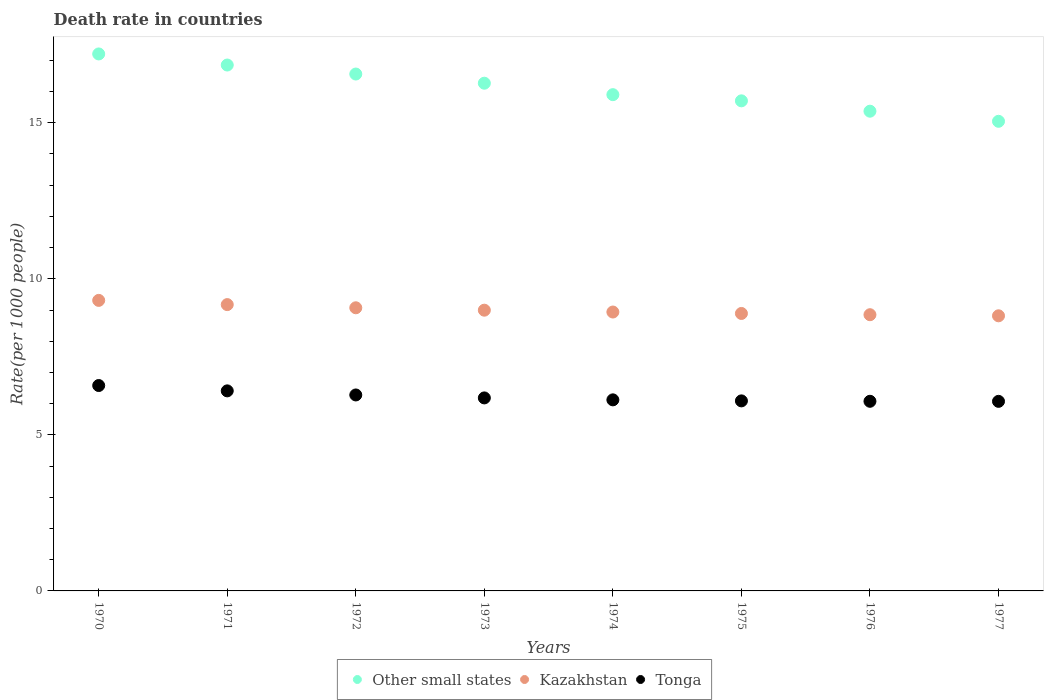How many different coloured dotlines are there?
Provide a short and direct response. 3. Is the number of dotlines equal to the number of legend labels?
Your answer should be compact. Yes. What is the death rate in Tonga in 1970?
Offer a very short reply. 6.58. Across all years, what is the maximum death rate in Kazakhstan?
Provide a succinct answer. 9.31. Across all years, what is the minimum death rate in Kazakhstan?
Your answer should be very brief. 8.81. In which year was the death rate in Kazakhstan maximum?
Your response must be concise. 1970. In which year was the death rate in Other small states minimum?
Provide a short and direct response. 1977. What is the total death rate in Tonga in the graph?
Provide a short and direct response. 49.82. What is the difference between the death rate in Kazakhstan in 1972 and that in 1973?
Your response must be concise. 0.08. What is the difference between the death rate in Kazakhstan in 1973 and the death rate in Tonga in 1976?
Offer a very short reply. 2.92. What is the average death rate in Kazakhstan per year?
Your answer should be very brief. 9.01. In the year 1977, what is the difference between the death rate in Tonga and death rate in Other small states?
Give a very brief answer. -8.97. In how many years, is the death rate in Other small states greater than 8?
Make the answer very short. 8. What is the ratio of the death rate in Tonga in 1970 to that in 1977?
Keep it short and to the point. 1.08. Is the difference between the death rate in Tonga in 1972 and 1977 greater than the difference between the death rate in Other small states in 1972 and 1977?
Keep it short and to the point. No. What is the difference between the highest and the second highest death rate in Tonga?
Make the answer very short. 0.17. What is the difference between the highest and the lowest death rate in Tonga?
Make the answer very short. 0.51. Is the sum of the death rate in Kazakhstan in 1971 and 1972 greater than the maximum death rate in Tonga across all years?
Keep it short and to the point. Yes. How many dotlines are there?
Keep it short and to the point. 3. How many years are there in the graph?
Keep it short and to the point. 8. What is the difference between two consecutive major ticks on the Y-axis?
Provide a succinct answer. 5. Does the graph contain any zero values?
Offer a terse response. No. Where does the legend appear in the graph?
Offer a very short reply. Bottom center. How many legend labels are there?
Keep it short and to the point. 3. How are the legend labels stacked?
Provide a succinct answer. Horizontal. What is the title of the graph?
Offer a terse response. Death rate in countries. Does "Low & middle income" appear as one of the legend labels in the graph?
Your answer should be very brief. No. What is the label or title of the X-axis?
Provide a succinct answer. Years. What is the label or title of the Y-axis?
Offer a very short reply. Rate(per 1000 people). What is the Rate(per 1000 people) of Other small states in 1970?
Your answer should be very brief. 17.21. What is the Rate(per 1000 people) of Kazakhstan in 1970?
Give a very brief answer. 9.31. What is the Rate(per 1000 people) in Tonga in 1970?
Provide a succinct answer. 6.58. What is the Rate(per 1000 people) of Other small states in 1971?
Make the answer very short. 16.85. What is the Rate(per 1000 people) in Kazakhstan in 1971?
Ensure brevity in your answer.  9.17. What is the Rate(per 1000 people) of Tonga in 1971?
Provide a short and direct response. 6.41. What is the Rate(per 1000 people) in Other small states in 1972?
Give a very brief answer. 16.56. What is the Rate(per 1000 people) in Kazakhstan in 1972?
Give a very brief answer. 9.07. What is the Rate(per 1000 people) in Tonga in 1972?
Your answer should be compact. 6.28. What is the Rate(per 1000 people) in Other small states in 1973?
Your answer should be very brief. 16.27. What is the Rate(per 1000 people) of Kazakhstan in 1973?
Ensure brevity in your answer.  8.99. What is the Rate(per 1000 people) of Tonga in 1973?
Make the answer very short. 6.18. What is the Rate(per 1000 people) in Other small states in 1974?
Make the answer very short. 15.9. What is the Rate(per 1000 people) in Kazakhstan in 1974?
Offer a terse response. 8.94. What is the Rate(per 1000 people) in Tonga in 1974?
Give a very brief answer. 6.12. What is the Rate(per 1000 people) in Other small states in 1975?
Make the answer very short. 15.7. What is the Rate(per 1000 people) of Kazakhstan in 1975?
Your answer should be very brief. 8.89. What is the Rate(per 1000 people) in Tonga in 1975?
Provide a short and direct response. 6.09. What is the Rate(per 1000 people) in Other small states in 1976?
Keep it short and to the point. 15.37. What is the Rate(per 1000 people) of Kazakhstan in 1976?
Provide a short and direct response. 8.85. What is the Rate(per 1000 people) of Tonga in 1976?
Offer a terse response. 6.08. What is the Rate(per 1000 people) of Other small states in 1977?
Your answer should be very brief. 15.05. What is the Rate(per 1000 people) in Kazakhstan in 1977?
Your answer should be compact. 8.81. What is the Rate(per 1000 people) of Tonga in 1977?
Provide a short and direct response. 6.07. Across all years, what is the maximum Rate(per 1000 people) of Other small states?
Offer a very short reply. 17.21. Across all years, what is the maximum Rate(per 1000 people) of Kazakhstan?
Your answer should be very brief. 9.31. Across all years, what is the maximum Rate(per 1000 people) of Tonga?
Offer a very short reply. 6.58. Across all years, what is the minimum Rate(per 1000 people) of Other small states?
Offer a very short reply. 15.05. Across all years, what is the minimum Rate(per 1000 people) of Kazakhstan?
Provide a short and direct response. 8.81. Across all years, what is the minimum Rate(per 1000 people) in Tonga?
Give a very brief answer. 6.07. What is the total Rate(per 1000 people) of Other small states in the graph?
Provide a succinct answer. 128.91. What is the total Rate(per 1000 people) in Kazakhstan in the graph?
Ensure brevity in your answer.  72.04. What is the total Rate(per 1000 people) of Tonga in the graph?
Provide a short and direct response. 49.81. What is the difference between the Rate(per 1000 people) in Other small states in 1970 and that in 1971?
Give a very brief answer. 0.36. What is the difference between the Rate(per 1000 people) of Kazakhstan in 1970 and that in 1971?
Keep it short and to the point. 0.14. What is the difference between the Rate(per 1000 people) in Tonga in 1970 and that in 1971?
Provide a succinct answer. 0.17. What is the difference between the Rate(per 1000 people) in Other small states in 1970 and that in 1972?
Your answer should be very brief. 0.64. What is the difference between the Rate(per 1000 people) in Kazakhstan in 1970 and that in 1972?
Your response must be concise. 0.24. What is the difference between the Rate(per 1000 people) in Tonga in 1970 and that in 1972?
Offer a terse response. 0.3. What is the difference between the Rate(per 1000 people) of Kazakhstan in 1970 and that in 1973?
Your answer should be compact. 0.31. What is the difference between the Rate(per 1000 people) in Tonga in 1970 and that in 1973?
Provide a short and direct response. 0.4. What is the difference between the Rate(per 1000 people) of Other small states in 1970 and that in 1974?
Offer a very short reply. 1.3. What is the difference between the Rate(per 1000 people) in Kazakhstan in 1970 and that in 1974?
Offer a terse response. 0.37. What is the difference between the Rate(per 1000 people) of Tonga in 1970 and that in 1974?
Keep it short and to the point. 0.46. What is the difference between the Rate(per 1000 people) in Other small states in 1970 and that in 1975?
Your response must be concise. 1.5. What is the difference between the Rate(per 1000 people) of Kazakhstan in 1970 and that in 1975?
Ensure brevity in your answer.  0.42. What is the difference between the Rate(per 1000 people) in Tonga in 1970 and that in 1975?
Your answer should be compact. 0.49. What is the difference between the Rate(per 1000 people) of Other small states in 1970 and that in 1976?
Provide a succinct answer. 1.83. What is the difference between the Rate(per 1000 people) in Kazakhstan in 1970 and that in 1976?
Offer a very short reply. 0.46. What is the difference between the Rate(per 1000 people) of Tonga in 1970 and that in 1976?
Your response must be concise. 0.51. What is the difference between the Rate(per 1000 people) in Other small states in 1970 and that in 1977?
Keep it short and to the point. 2.16. What is the difference between the Rate(per 1000 people) of Kazakhstan in 1970 and that in 1977?
Give a very brief answer. 0.49. What is the difference between the Rate(per 1000 people) of Tonga in 1970 and that in 1977?
Offer a very short reply. 0.51. What is the difference between the Rate(per 1000 people) of Other small states in 1971 and that in 1972?
Provide a succinct answer. 0.29. What is the difference between the Rate(per 1000 people) in Kazakhstan in 1971 and that in 1972?
Your response must be concise. 0.1. What is the difference between the Rate(per 1000 people) of Tonga in 1971 and that in 1972?
Ensure brevity in your answer.  0.13. What is the difference between the Rate(per 1000 people) in Other small states in 1971 and that in 1973?
Offer a very short reply. 0.58. What is the difference between the Rate(per 1000 people) of Kazakhstan in 1971 and that in 1973?
Provide a short and direct response. 0.18. What is the difference between the Rate(per 1000 people) in Tonga in 1971 and that in 1973?
Offer a terse response. 0.23. What is the difference between the Rate(per 1000 people) of Other small states in 1971 and that in 1974?
Provide a succinct answer. 0.95. What is the difference between the Rate(per 1000 people) in Kazakhstan in 1971 and that in 1974?
Your answer should be compact. 0.24. What is the difference between the Rate(per 1000 people) of Tonga in 1971 and that in 1974?
Provide a short and direct response. 0.29. What is the difference between the Rate(per 1000 people) in Other small states in 1971 and that in 1975?
Ensure brevity in your answer.  1.15. What is the difference between the Rate(per 1000 people) in Kazakhstan in 1971 and that in 1975?
Your response must be concise. 0.28. What is the difference between the Rate(per 1000 people) of Tonga in 1971 and that in 1975?
Make the answer very short. 0.32. What is the difference between the Rate(per 1000 people) in Other small states in 1971 and that in 1976?
Make the answer very short. 1.48. What is the difference between the Rate(per 1000 people) in Kazakhstan in 1971 and that in 1976?
Offer a very short reply. 0.32. What is the difference between the Rate(per 1000 people) in Tonga in 1971 and that in 1976?
Offer a terse response. 0.33. What is the difference between the Rate(per 1000 people) of Other small states in 1971 and that in 1977?
Provide a succinct answer. 1.8. What is the difference between the Rate(per 1000 people) in Kazakhstan in 1971 and that in 1977?
Provide a succinct answer. 0.36. What is the difference between the Rate(per 1000 people) in Tonga in 1971 and that in 1977?
Provide a short and direct response. 0.34. What is the difference between the Rate(per 1000 people) of Other small states in 1972 and that in 1973?
Provide a succinct answer. 0.29. What is the difference between the Rate(per 1000 people) in Kazakhstan in 1972 and that in 1973?
Make the answer very short. 0.08. What is the difference between the Rate(per 1000 people) in Tonga in 1972 and that in 1973?
Your answer should be compact. 0.1. What is the difference between the Rate(per 1000 people) of Other small states in 1972 and that in 1974?
Provide a succinct answer. 0.66. What is the difference between the Rate(per 1000 people) in Kazakhstan in 1972 and that in 1974?
Make the answer very short. 0.14. What is the difference between the Rate(per 1000 people) in Tonga in 1972 and that in 1974?
Your answer should be compact. 0.16. What is the difference between the Rate(per 1000 people) of Other small states in 1972 and that in 1975?
Your response must be concise. 0.86. What is the difference between the Rate(per 1000 people) in Kazakhstan in 1972 and that in 1975?
Your answer should be compact. 0.18. What is the difference between the Rate(per 1000 people) of Tonga in 1972 and that in 1975?
Provide a short and direct response. 0.19. What is the difference between the Rate(per 1000 people) in Other small states in 1972 and that in 1976?
Offer a terse response. 1.19. What is the difference between the Rate(per 1000 people) of Kazakhstan in 1972 and that in 1976?
Your answer should be very brief. 0.22. What is the difference between the Rate(per 1000 people) of Tonga in 1972 and that in 1976?
Ensure brevity in your answer.  0.2. What is the difference between the Rate(per 1000 people) of Other small states in 1972 and that in 1977?
Provide a short and direct response. 1.51. What is the difference between the Rate(per 1000 people) of Kazakhstan in 1972 and that in 1977?
Ensure brevity in your answer.  0.26. What is the difference between the Rate(per 1000 people) of Tonga in 1972 and that in 1977?
Give a very brief answer. 0.2. What is the difference between the Rate(per 1000 people) of Other small states in 1973 and that in 1974?
Keep it short and to the point. 0.37. What is the difference between the Rate(per 1000 people) of Kazakhstan in 1973 and that in 1974?
Offer a very short reply. 0.06. What is the difference between the Rate(per 1000 people) in Tonga in 1973 and that in 1974?
Your answer should be very brief. 0.06. What is the difference between the Rate(per 1000 people) of Other small states in 1973 and that in 1975?
Offer a very short reply. 0.57. What is the difference between the Rate(per 1000 people) in Kazakhstan in 1973 and that in 1975?
Provide a succinct answer. 0.1. What is the difference between the Rate(per 1000 people) of Tonga in 1973 and that in 1975?
Your answer should be compact. 0.1. What is the difference between the Rate(per 1000 people) in Other small states in 1973 and that in 1976?
Your response must be concise. 0.9. What is the difference between the Rate(per 1000 people) of Kazakhstan in 1973 and that in 1976?
Your answer should be very brief. 0.14. What is the difference between the Rate(per 1000 people) of Tonga in 1973 and that in 1976?
Offer a very short reply. 0.11. What is the difference between the Rate(per 1000 people) in Other small states in 1973 and that in 1977?
Offer a very short reply. 1.22. What is the difference between the Rate(per 1000 people) in Kazakhstan in 1973 and that in 1977?
Offer a very short reply. 0.18. What is the difference between the Rate(per 1000 people) of Tonga in 1973 and that in 1977?
Offer a very short reply. 0.11. What is the difference between the Rate(per 1000 people) of Other small states in 1974 and that in 1975?
Keep it short and to the point. 0.2. What is the difference between the Rate(per 1000 people) of Kazakhstan in 1974 and that in 1975?
Your response must be concise. 0.05. What is the difference between the Rate(per 1000 people) of Tonga in 1974 and that in 1975?
Keep it short and to the point. 0.03. What is the difference between the Rate(per 1000 people) of Other small states in 1974 and that in 1976?
Offer a terse response. 0.53. What is the difference between the Rate(per 1000 people) of Kazakhstan in 1974 and that in 1976?
Provide a short and direct response. 0.09. What is the difference between the Rate(per 1000 people) of Tonga in 1974 and that in 1976?
Ensure brevity in your answer.  0.05. What is the difference between the Rate(per 1000 people) of Other small states in 1974 and that in 1977?
Ensure brevity in your answer.  0.85. What is the difference between the Rate(per 1000 people) of Kazakhstan in 1974 and that in 1977?
Keep it short and to the point. 0.12. What is the difference between the Rate(per 1000 people) in Tonga in 1974 and that in 1977?
Offer a terse response. 0.05. What is the difference between the Rate(per 1000 people) in Other small states in 1975 and that in 1976?
Make the answer very short. 0.33. What is the difference between the Rate(per 1000 people) of Kazakhstan in 1975 and that in 1976?
Your answer should be very brief. 0.04. What is the difference between the Rate(per 1000 people) in Tonga in 1975 and that in 1976?
Your answer should be compact. 0.01. What is the difference between the Rate(per 1000 people) of Other small states in 1975 and that in 1977?
Your answer should be very brief. 0.66. What is the difference between the Rate(per 1000 people) of Kazakhstan in 1975 and that in 1977?
Provide a short and direct response. 0.07. What is the difference between the Rate(per 1000 people) of Tonga in 1975 and that in 1977?
Your answer should be very brief. 0.01. What is the difference between the Rate(per 1000 people) of Other small states in 1976 and that in 1977?
Offer a terse response. 0.32. What is the difference between the Rate(per 1000 people) in Kazakhstan in 1976 and that in 1977?
Offer a very short reply. 0.04. What is the difference between the Rate(per 1000 people) of Tonga in 1976 and that in 1977?
Your response must be concise. 0. What is the difference between the Rate(per 1000 people) of Other small states in 1970 and the Rate(per 1000 people) of Kazakhstan in 1971?
Provide a succinct answer. 8.03. What is the difference between the Rate(per 1000 people) of Other small states in 1970 and the Rate(per 1000 people) of Tonga in 1971?
Make the answer very short. 10.8. What is the difference between the Rate(per 1000 people) in Kazakhstan in 1970 and the Rate(per 1000 people) in Tonga in 1971?
Ensure brevity in your answer.  2.9. What is the difference between the Rate(per 1000 people) in Other small states in 1970 and the Rate(per 1000 people) in Kazakhstan in 1972?
Ensure brevity in your answer.  8.13. What is the difference between the Rate(per 1000 people) of Other small states in 1970 and the Rate(per 1000 people) of Tonga in 1972?
Your response must be concise. 10.93. What is the difference between the Rate(per 1000 people) in Kazakhstan in 1970 and the Rate(per 1000 people) in Tonga in 1972?
Ensure brevity in your answer.  3.03. What is the difference between the Rate(per 1000 people) of Other small states in 1970 and the Rate(per 1000 people) of Kazakhstan in 1973?
Provide a short and direct response. 8.21. What is the difference between the Rate(per 1000 people) in Other small states in 1970 and the Rate(per 1000 people) in Tonga in 1973?
Keep it short and to the point. 11.02. What is the difference between the Rate(per 1000 people) of Kazakhstan in 1970 and the Rate(per 1000 people) of Tonga in 1973?
Give a very brief answer. 3.12. What is the difference between the Rate(per 1000 people) in Other small states in 1970 and the Rate(per 1000 people) in Kazakhstan in 1974?
Provide a short and direct response. 8.27. What is the difference between the Rate(per 1000 people) in Other small states in 1970 and the Rate(per 1000 people) in Tonga in 1974?
Give a very brief answer. 11.08. What is the difference between the Rate(per 1000 people) in Kazakhstan in 1970 and the Rate(per 1000 people) in Tonga in 1974?
Your response must be concise. 3.19. What is the difference between the Rate(per 1000 people) in Other small states in 1970 and the Rate(per 1000 people) in Kazakhstan in 1975?
Provide a short and direct response. 8.32. What is the difference between the Rate(per 1000 people) of Other small states in 1970 and the Rate(per 1000 people) of Tonga in 1975?
Provide a succinct answer. 11.12. What is the difference between the Rate(per 1000 people) in Kazakhstan in 1970 and the Rate(per 1000 people) in Tonga in 1975?
Provide a succinct answer. 3.22. What is the difference between the Rate(per 1000 people) in Other small states in 1970 and the Rate(per 1000 people) in Kazakhstan in 1976?
Give a very brief answer. 8.36. What is the difference between the Rate(per 1000 people) of Other small states in 1970 and the Rate(per 1000 people) of Tonga in 1976?
Give a very brief answer. 11.13. What is the difference between the Rate(per 1000 people) in Kazakhstan in 1970 and the Rate(per 1000 people) in Tonga in 1976?
Offer a very short reply. 3.23. What is the difference between the Rate(per 1000 people) in Other small states in 1970 and the Rate(per 1000 people) in Kazakhstan in 1977?
Your answer should be very brief. 8.39. What is the difference between the Rate(per 1000 people) in Other small states in 1970 and the Rate(per 1000 people) in Tonga in 1977?
Make the answer very short. 11.13. What is the difference between the Rate(per 1000 people) in Kazakhstan in 1970 and the Rate(per 1000 people) in Tonga in 1977?
Provide a succinct answer. 3.23. What is the difference between the Rate(per 1000 people) of Other small states in 1971 and the Rate(per 1000 people) of Kazakhstan in 1972?
Ensure brevity in your answer.  7.78. What is the difference between the Rate(per 1000 people) of Other small states in 1971 and the Rate(per 1000 people) of Tonga in 1972?
Provide a short and direct response. 10.57. What is the difference between the Rate(per 1000 people) of Kazakhstan in 1971 and the Rate(per 1000 people) of Tonga in 1972?
Give a very brief answer. 2.9. What is the difference between the Rate(per 1000 people) of Other small states in 1971 and the Rate(per 1000 people) of Kazakhstan in 1973?
Provide a short and direct response. 7.86. What is the difference between the Rate(per 1000 people) in Other small states in 1971 and the Rate(per 1000 people) in Tonga in 1973?
Provide a short and direct response. 10.67. What is the difference between the Rate(per 1000 people) in Kazakhstan in 1971 and the Rate(per 1000 people) in Tonga in 1973?
Provide a succinct answer. 2.99. What is the difference between the Rate(per 1000 people) in Other small states in 1971 and the Rate(per 1000 people) in Kazakhstan in 1974?
Offer a terse response. 7.91. What is the difference between the Rate(per 1000 people) in Other small states in 1971 and the Rate(per 1000 people) in Tonga in 1974?
Ensure brevity in your answer.  10.73. What is the difference between the Rate(per 1000 people) in Kazakhstan in 1971 and the Rate(per 1000 people) in Tonga in 1974?
Your answer should be very brief. 3.05. What is the difference between the Rate(per 1000 people) of Other small states in 1971 and the Rate(per 1000 people) of Kazakhstan in 1975?
Ensure brevity in your answer.  7.96. What is the difference between the Rate(per 1000 people) of Other small states in 1971 and the Rate(per 1000 people) of Tonga in 1975?
Keep it short and to the point. 10.76. What is the difference between the Rate(per 1000 people) in Kazakhstan in 1971 and the Rate(per 1000 people) in Tonga in 1975?
Make the answer very short. 3.08. What is the difference between the Rate(per 1000 people) in Other small states in 1971 and the Rate(per 1000 people) in Tonga in 1976?
Keep it short and to the point. 10.77. What is the difference between the Rate(per 1000 people) of Kazakhstan in 1971 and the Rate(per 1000 people) of Tonga in 1976?
Provide a short and direct response. 3.1. What is the difference between the Rate(per 1000 people) in Other small states in 1971 and the Rate(per 1000 people) in Kazakhstan in 1977?
Your answer should be compact. 8.04. What is the difference between the Rate(per 1000 people) of Other small states in 1971 and the Rate(per 1000 people) of Tonga in 1977?
Provide a succinct answer. 10.78. What is the difference between the Rate(per 1000 people) in Other small states in 1972 and the Rate(per 1000 people) in Kazakhstan in 1973?
Make the answer very short. 7.57. What is the difference between the Rate(per 1000 people) in Other small states in 1972 and the Rate(per 1000 people) in Tonga in 1973?
Give a very brief answer. 10.38. What is the difference between the Rate(per 1000 people) in Kazakhstan in 1972 and the Rate(per 1000 people) in Tonga in 1973?
Make the answer very short. 2.89. What is the difference between the Rate(per 1000 people) of Other small states in 1972 and the Rate(per 1000 people) of Kazakhstan in 1974?
Your answer should be very brief. 7.63. What is the difference between the Rate(per 1000 people) of Other small states in 1972 and the Rate(per 1000 people) of Tonga in 1974?
Ensure brevity in your answer.  10.44. What is the difference between the Rate(per 1000 people) of Kazakhstan in 1972 and the Rate(per 1000 people) of Tonga in 1974?
Provide a short and direct response. 2.95. What is the difference between the Rate(per 1000 people) in Other small states in 1972 and the Rate(per 1000 people) in Kazakhstan in 1975?
Your answer should be very brief. 7.67. What is the difference between the Rate(per 1000 people) in Other small states in 1972 and the Rate(per 1000 people) in Tonga in 1975?
Give a very brief answer. 10.47. What is the difference between the Rate(per 1000 people) of Kazakhstan in 1972 and the Rate(per 1000 people) of Tonga in 1975?
Your answer should be very brief. 2.98. What is the difference between the Rate(per 1000 people) in Other small states in 1972 and the Rate(per 1000 people) in Kazakhstan in 1976?
Make the answer very short. 7.71. What is the difference between the Rate(per 1000 people) of Other small states in 1972 and the Rate(per 1000 people) of Tonga in 1976?
Ensure brevity in your answer.  10.49. What is the difference between the Rate(per 1000 people) in Kazakhstan in 1972 and the Rate(per 1000 people) in Tonga in 1976?
Keep it short and to the point. 3. What is the difference between the Rate(per 1000 people) of Other small states in 1972 and the Rate(per 1000 people) of Kazakhstan in 1977?
Provide a succinct answer. 7.75. What is the difference between the Rate(per 1000 people) of Other small states in 1972 and the Rate(per 1000 people) of Tonga in 1977?
Your response must be concise. 10.49. What is the difference between the Rate(per 1000 people) in Kazakhstan in 1972 and the Rate(per 1000 people) in Tonga in 1977?
Make the answer very short. 3. What is the difference between the Rate(per 1000 people) in Other small states in 1973 and the Rate(per 1000 people) in Kazakhstan in 1974?
Your answer should be very brief. 7.33. What is the difference between the Rate(per 1000 people) in Other small states in 1973 and the Rate(per 1000 people) in Tonga in 1974?
Offer a terse response. 10.15. What is the difference between the Rate(per 1000 people) in Kazakhstan in 1973 and the Rate(per 1000 people) in Tonga in 1974?
Make the answer very short. 2.87. What is the difference between the Rate(per 1000 people) in Other small states in 1973 and the Rate(per 1000 people) in Kazakhstan in 1975?
Offer a terse response. 7.38. What is the difference between the Rate(per 1000 people) of Other small states in 1973 and the Rate(per 1000 people) of Tonga in 1975?
Your answer should be compact. 10.18. What is the difference between the Rate(per 1000 people) of Kazakhstan in 1973 and the Rate(per 1000 people) of Tonga in 1975?
Provide a short and direct response. 2.91. What is the difference between the Rate(per 1000 people) of Other small states in 1973 and the Rate(per 1000 people) of Kazakhstan in 1976?
Your answer should be very brief. 7.42. What is the difference between the Rate(per 1000 people) of Other small states in 1973 and the Rate(per 1000 people) of Tonga in 1976?
Your answer should be very brief. 10.19. What is the difference between the Rate(per 1000 people) of Kazakhstan in 1973 and the Rate(per 1000 people) of Tonga in 1976?
Offer a terse response. 2.92. What is the difference between the Rate(per 1000 people) of Other small states in 1973 and the Rate(per 1000 people) of Kazakhstan in 1977?
Provide a short and direct response. 7.45. What is the difference between the Rate(per 1000 people) in Other small states in 1973 and the Rate(per 1000 people) in Tonga in 1977?
Provide a succinct answer. 10.19. What is the difference between the Rate(per 1000 people) of Kazakhstan in 1973 and the Rate(per 1000 people) of Tonga in 1977?
Provide a succinct answer. 2.92. What is the difference between the Rate(per 1000 people) of Other small states in 1974 and the Rate(per 1000 people) of Kazakhstan in 1975?
Offer a very short reply. 7.01. What is the difference between the Rate(per 1000 people) of Other small states in 1974 and the Rate(per 1000 people) of Tonga in 1975?
Give a very brief answer. 9.81. What is the difference between the Rate(per 1000 people) of Kazakhstan in 1974 and the Rate(per 1000 people) of Tonga in 1975?
Your response must be concise. 2.85. What is the difference between the Rate(per 1000 people) of Other small states in 1974 and the Rate(per 1000 people) of Kazakhstan in 1976?
Make the answer very short. 7.05. What is the difference between the Rate(per 1000 people) in Other small states in 1974 and the Rate(per 1000 people) in Tonga in 1976?
Provide a succinct answer. 9.82. What is the difference between the Rate(per 1000 people) in Kazakhstan in 1974 and the Rate(per 1000 people) in Tonga in 1976?
Your answer should be compact. 2.86. What is the difference between the Rate(per 1000 people) in Other small states in 1974 and the Rate(per 1000 people) in Kazakhstan in 1977?
Your answer should be very brief. 7.09. What is the difference between the Rate(per 1000 people) of Other small states in 1974 and the Rate(per 1000 people) of Tonga in 1977?
Offer a terse response. 9.83. What is the difference between the Rate(per 1000 people) of Kazakhstan in 1974 and the Rate(per 1000 people) of Tonga in 1977?
Ensure brevity in your answer.  2.86. What is the difference between the Rate(per 1000 people) of Other small states in 1975 and the Rate(per 1000 people) of Kazakhstan in 1976?
Provide a succinct answer. 6.85. What is the difference between the Rate(per 1000 people) in Other small states in 1975 and the Rate(per 1000 people) in Tonga in 1976?
Your answer should be very brief. 9.63. What is the difference between the Rate(per 1000 people) of Kazakhstan in 1975 and the Rate(per 1000 people) of Tonga in 1976?
Ensure brevity in your answer.  2.81. What is the difference between the Rate(per 1000 people) in Other small states in 1975 and the Rate(per 1000 people) in Kazakhstan in 1977?
Your answer should be very brief. 6.89. What is the difference between the Rate(per 1000 people) in Other small states in 1975 and the Rate(per 1000 people) in Tonga in 1977?
Offer a terse response. 9.63. What is the difference between the Rate(per 1000 people) in Kazakhstan in 1975 and the Rate(per 1000 people) in Tonga in 1977?
Ensure brevity in your answer.  2.82. What is the difference between the Rate(per 1000 people) of Other small states in 1976 and the Rate(per 1000 people) of Kazakhstan in 1977?
Provide a succinct answer. 6.56. What is the difference between the Rate(per 1000 people) of Other small states in 1976 and the Rate(per 1000 people) of Tonga in 1977?
Your answer should be very brief. 9.3. What is the difference between the Rate(per 1000 people) of Kazakhstan in 1976 and the Rate(per 1000 people) of Tonga in 1977?
Keep it short and to the point. 2.78. What is the average Rate(per 1000 people) in Other small states per year?
Your answer should be compact. 16.11. What is the average Rate(per 1000 people) of Kazakhstan per year?
Offer a terse response. 9.01. What is the average Rate(per 1000 people) in Tonga per year?
Offer a terse response. 6.23. In the year 1970, what is the difference between the Rate(per 1000 people) of Other small states and Rate(per 1000 people) of Kazakhstan?
Ensure brevity in your answer.  7.9. In the year 1970, what is the difference between the Rate(per 1000 people) in Other small states and Rate(per 1000 people) in Tonga?
Give a very brief answer. 10.62. In the year 1970, what is the difference between the Rate(per 1000 people) in Kazakhstan and Rate(per 1000 people) in Tonga?
Offer a very short reply. 2.73. In the year 1971, what is the difference between the Rate(per 1000 people) in Other small states and Rate(per 1000 people) in Kazakhstan?
Offer a terse response. 7.68. In the year 1971, what is the difference between the Rate(per 1000 people) of Other small states and Rate(per 1000 people) of Tonga?
Your answer should be compact. 10.44. In the year 1971, what is the difference between the Rate(per 1000 people) in Kazakhstan and Rate(per 1000 people) in Tonga?
Ensure brevity in your answer.  2.76. In the year 1972, what is the difference between the Rate(per 1000 people) of Other small states and Rate(per 1000 people) of Kazakhstan?
Offer a very short reply. 7.49. In the year 1972, what is the difference between the Rate(per 1000 people) of Other small states and Rate(per 1000 people) of Tonga?
Offer a terse response. 10.28. In the year 1972, what is the difference between the Rate(per 1000 people) of Kazakhstan and Rate(per 1000 people) of Tonga?
Keep it short and to the point. 2.79. In the year 1973, what is the difference between the Rate(per 1000 people) of Other small states and Rate(per 1000 people) of Kazakhstan?
Provide a short and direct response. 7.27. In the year 1973, what is the difference between the Rate(per 1000 people) of Other small states and Rate(per 1000 people) of Tonga?
Your answer should be compact. 10.08. In the year 1973, what is the difference between the Rate(per 1000 people) in Kazakhstan and Rate(per 1000 people) in Tonga?
Offer a terse response. 2.81. In the year 1974, what is the difference between the Rate(per 1000 people) of Other small states and Rate(per 1000 people) of Kazakhstan?
Your response must be concise. 6.96. In the year 1974, what is the difference between the Rate(per 1000 people) of Other small states and Rate(per 1000 people) of Tonga?
Give a very brief answer. 9.78. In the year 1974, what is the difference between the Rate(per 1000 people) in Kazakhstan and Rate(per 1000 people) in Tonga?
Keep it short and to the point. 2.81. In the year 1975, what is the difference between the Rate(per 1000 people) of Other small states and Rate(per 1000 people) of Kazakhstan?
Offer a terse response. 6.81. In the year 1975, what is the difference between the Rate(per 1000 people) of Other small states and Rate(per 1000 people) of Tonga?
Provide a succinct answer. 9.61. In the year 1975, what is the difference between the Rate(per 1000 people) in Kazakhstan and Rate(per 1000 people) in Tonga?
Ensure brevity in your answer.  2.8. In the year 1976, what is the difference between the Rate(per 1000 people) of Other small states and Rate(per 1000 people) of Kazakhstan?
Ensure brevity in your answer.  6.52. In the year 1976, what is the difference between the Rate(per 1000 people) of Other small states and Rate(per 1000 people) of Tonga?
Offer a terse response. 9.29. In the year 1976, what is the difference between the Rate(per 1000 people) of Kazakhstan and Rate(per 1000 people) of Tonga?
Offer a very short reply. 2.77. In the year 1977, what is the difference between the Rate(per 1000 people) of Other small states and Rate(per 1000 people) of Kazakhstan?
Offer a terse response. 6.23. In the year 1977, what is the difference between the Rate(per 1000 people) of Other small states and Rate(per 1000 people) of Tonga?
Your answer should be very brief. 8.97. In the year 1977, what is the difference between the Rate(per 1000 people) in Kazakhstan and Rate(per 1000 people) in Tonga?
Provide a succinct answer. 2.74. What is the ratio of the Rate(per 1000 people) in Other small states in 1970 to that in 1971?
Offer a very short reply. 1.02. What is the ratio of the Rate(per 1000 people) of Kazakhstan in 1970 to that in 1971?
Give a very brief answer. 1.01. What is the ratio of the Rate(per 1000 people) in Tonga in 1970 to that in 1971?
Provide a short and direct response. 1.03. What is the ratio of the Rate(per 1000 people) in Other small states in 1970 to that in 1972?
Your answer should be compact. 1.04. What is the ratio of the Rate(per 1000 people) of Kazakhstan in 1970 to that in 1972?
Offer a very short reply. 1.03. What is the ratio of the Rate(per 1000 people) of Tonga in 1970 to that in 1972?
Offer a very short reply. 1.05. What is the ratio of the Rate(per 1000 people) in Other small states in 1970 to that in 1973?
Your answer should be very brief. 1.06. What is the ratio of the Rate(per 1000 people) in Kazakhstan in 1970 to that in 1973?
Ensure brevity in your answer.  1.03. What is the ratio of the Rate(per 1000 people) in Tonga in 1970 to that in 1973?
Keep it short and to the point. 1.06. What is the ratio of the Rate(per 1000 people) in Other small states in 1970 to that in 1974?
Your answer should be very brief. 1.08. What is the ratio of the Rate(per 1000 people) of Kazakhstan in 1970 to that in 1974?
Give a very brief answer. 1.04. What is the ratio of the Rate(per 1000 people) of Tonga in 1970 to that in 1974?
Offer a terse response. 1.07. What is the ratio of the Rate(per 1000 people) of Other small states in 1970 to that in 1975?
Offer a terse response. 1.1. What is the ratio of the Rate(per 1000 people) of Kazakhstan in 1970 to that in 1975?
Provide a succinct answer. 1.05. What is the ratio of the Rate(per 1000 people) in Tonga in 1970 to that in 1975?
Offer a terse response. 1.08. What is the ratio of the Rate(per 1000 people) in Other small states in 1970 to that in 1976?
Provide a short and direct response. 1.12. What is the ratio of the Rate(per 1000 people) in Kazakhstan in 1970 to that in 1976?
Keep it short and to the point. 1.05. What is the ratio of the Rate(per 1000 people) of Tonga in 1970 to that in 1976?
Offer a very short reply. 1.08. What is the ratio of the Rate(per 1000 people) of Other small states in 1970 to that in 1977?
Your answer should be very brief. 1.14. What is the ratio of the Rate(per 1000 people) in Kazakhstan in 1970 to that in 1977?
Give a very brief answer. 1.06. What is the ratio of the Rate(per 1000 people) in Tonga in 1970 to that in 1977?
Provide a short and direct response. 1.08. What is the ratio of the Rate(per 1000 people) in Other small states in 1971 to that in 1972?
Your answer should be very brief. 1.02. What is the ratio of the Rate(per 1000 people) in Kazakhstan in 1971 to that in 1972?
Keep it short and to the point. 1.01. What is the ratio of the Rate(per 1000 people) in Tonga in 1971 to that in 1972?
Make the answer very short. 1.02. What is the ratio of the Rate(per 1000 people) of Other small states in 1971 to that in 1973?
Give a very brief answer. 1.04. What is the ratio of the Rate(per 1000 people) in Kazakhstan in 1971 to that in 1973?
Provide a short and direct response. 1.02. What is the ratio of the Rate(per 1000 people) in Tonga in 1971 to that in 1973?
Ensure brevity in your answer.  1.04. What is the ratio of the Rate(per 1000 people) in Other small states in 1971 to that in 1974?
Your answer should be compact. 1.06. What is the ratio of the Rate(per 1000 people) of Kazakhstan in 1971 to that in 1974?
Provide a short and direct response. 1.03. What is the ratio of the Rate(per 1000 people) in Tonga in 1971 to that in 1974?
Give a very brief answer. 1.05. What is the ratio of the Rate(per 1000 people) in Other small states in 1971 to that in 1975?
Give a very brief answer. 1.07. What is the ratio of the Rate(per 1000 people) in Kazakhstan in 1971 to that in 1975?
Give a very brief answer. 1.03. What is the ratio of the Rate(per 1000 people) of Tonga in 1971 to that in 1975?
Your answer should be compact. 1.05. What is the ratio of the Rate(per 1000 people) of Other small states in 1971 to that in 1976?
Offer a terse response. 1.1. What is the ratio of the Rate(per 1000 people) of Kazakhstan in 1971 to that in 1976?
Keep it short and to the point. 1.04. What is the ratio of the Rate(per 1000 people) in Tonga in 1971 to that in 1976?
Offer a terse response. 1.05. What is the ratio of the Rate(per 1000 people) of Other small states in 1971 to that in 1977?
Your response must be concise. 1.12. What is the ratio of the Rate(per 1000 people) of Kazakhstan in 1971 to that in 1977?
Your response must be concise. 1.04. What is the ratio of the Rate(per 1000 people) in Tonga in 1971 to that in 1977?
Give a very brief answer. 1.06. What is the ratio of the Rate(per 1000 people) of Other small states in 1972 to that in 1973?
Ensure brevity in your answer.  1.02. What is the ratio of the Rate(per 1000 people) of Kazakhstan in 1972 to that in 1973?
Provide a short and direct response. 1.01. What is the ratio of the Rate(per 1000 people) of Tonga in 1972 to that in 1973?
Offer a terse response. 1.02. What is the ratio of the Rate(per 1000 people) of Other small states in 1972 to that in 1974?
Your answer should be very brief. 1.04. What is the ratio of the Rate(per 1000 people) of Kazakhstan in 1972 to that in 1974?
Your answer should be compact. 1.02. What is the ratio of the Rate(per 1000 people) in Tonga in 1972 to that in 1974?
Provide a short and direct response. 1.03. What is the ratio of the Rate(per 1000 people) in Other small states in 1972 to that in 1975?
Provide a short and direct response. 1.05. What is the ratio of the Rate(per 1000 people) in Kazakhstan in 1972 to that in 1975?
Offer a terse response. 1.02. What is the ratio of the Rate(per 1000 people) of Tonga in 1972 to that in 1975?
Offer a very short reply. 1.03. What is the ratio of the Rate(per 1000 people) of Other small states in 1972 to that in 1976?
Your answer should be compact. 1.08. What is the ratio of the Rate(per 1000 people) in Kazakhstan in 1972 to that in 1976?
Your response must be concise. 1.03. What is the ratio of the Rate(per 1000 people) in Tonga in 1972 to that in 1976?
Your answer should be compact. 1.03. What is the ratio of the Rate(per 1000 people) of Other small states in 1972 to that in 1977?
Your response must be concise. 1.1. What is the ratio of the Rate(per 1000 people) of Kazakhstan in 1972 to that in 1977?
Your response must be concise. 1.03. What is the ratio of the Rate(per 1000 people) of Tonga in 1972 to that in 1977?
Make the answer very short. 1.03. What is the ratio of the Rate(per 1000 people) of Other small states in 1973 to that in 1974?
Ensure brevity in your answer.  1.02. What is the ratio of the Rate(per 1000 people) in Kazakhstan in 1973 to that in 1974?
Your answer should be very brief. 1.01. What is the ratio of the Rate(per 1000 people) in Tonga in 1973 to that in 1974?
Keep it short and to the point. 1.01. What is the ratio of the Rate(per 1000 people) of Other small states in 1973 to that in 1975?
Keep it short and to the point. 1.04. What is the ratio of the Rate(per 1000 people) in Kazakhstan in 1973 to that in 1975?
Provide a succinct answer. 1.01. What is the ratio of the Rate(per 1000 people) of Tonga in 1973 to that in 1975?
Provide a succinct answer. 1.02. What is the ratio of the Rate(per 1000 people) in Other small states in 1973 to that in 1976?
Your answer should be very brief. 1.06. What is the ratio of the Rate(per 1000 people) in Kazakhstan in 1973 to that in 1976?
Ensure brevity in your answer.  1.02. What is the ratio of the Rate(per 1000 people) of Tonga in 1973 to that in 1976?
Offer a terse response. 1.02. What is the ratio of the Rate(per 1000 people) in Other small states in 1973 to that in 1977?
Your answer should be very brief. 1.08. What is the ratio of the Rate(per 1000 people) in Kazakhstan in 1973 to that in 1977?
Give a very brief answer. 1.02. What is the ratio of the Rate(per 1000 people) of Tonga in 1973 to that in 1977?
Make the answer very short. 1.02. What is the ratio of the Rate(per 1000 people) in Other small states in 1974 to that in 1975?
Your answer should be compact. 1.01. What is the ratio of the Rate(per 1000 people) in Kazakhstan in 1974 to that in 1975?
Ensure brevity in your answer.  1.01. What is the ratio of the Rate(per 1000 people) of Tonga in 1974 to that in 1975?
Your answer should be very brief. 1.01. What is the ratio of the Rate(per 1000 people) in Other small states in 1974 to that in 1976?
Keep it short and to the point. 1.03. What is the ratio of the Rate(per 1000 people) of Kazakhstan in 1974 to that in 1976?
Provide a short and direct response. 1.01. What is the ratio of the Rate(per 1000 people) in Tonga in 1974 to that in 1976?
Make the answer very short. 1.01. What is the ratio of the Rate(per 1000 people) of Other small states in 1974 to that in 1977?
Ensure brevity in your answer.  1.06. What is the ratio of the Rate(per 1000 people) in Kazakhstan in 1974 to that in 1977?
Offer a terse response. 1.01. What is the ratio of the Rate(per 1000 people) in Tonga in 1974 to that in 1977?
Offer a terse response. 1.01. What is the ratio of the Rate(per 1000 people) of Other small states in 1975 to that in 1976?
Your answer should be compact. 1.02. What is the ratio of the Rate(per 1000 people) in Kazakhstan in 1975 to that in 1976?
Ensure brevity in your answer.  1. What is the ratio of the Rate(per 1000 people) in Other small states in 1975 to that in 1977?
Give a very brief answer. 1.04. What is the ratio of the Rate(per 1000 people) in Kazakhstan in 1975 to that in 1977?
Provide a succinct answer. 1.01. What is the ratio of the Rate(per 1000 people) in Tonga in 1975 to that in 1977?
Offer a very short reply. 1. What is the ratio of the Rate(per 1000 people) in Other small states in 1976 to that in 1977?
Provide a short and direct response. 1.02. What is the difference between the highest and the second highest Rate(per 1000 people) of Other small states?
Offer a very short reply. 0.36. What is the difference between the highest and the second highest Rate(per 1000 people) of Kazakhstan?
Your answer should be very brief. 0.14. What is the difference between the highest and the second highest Rate(per 1000 people) of Tonga?
Your response must be concise. 0.17. What is the difference between the highest and the lowest Rate(per 1000 people) of Other small states?
Keep it short and to the point. 2.16. What is the difference between the highest and the lowest Rate(per 1000 people) in Kazakhstan?
Make the answer very short. 0.49. What is the difference between the highest and the lowest Rate(per 1000 people) in Tonga?
Provide a short and direct response. 0.51. 